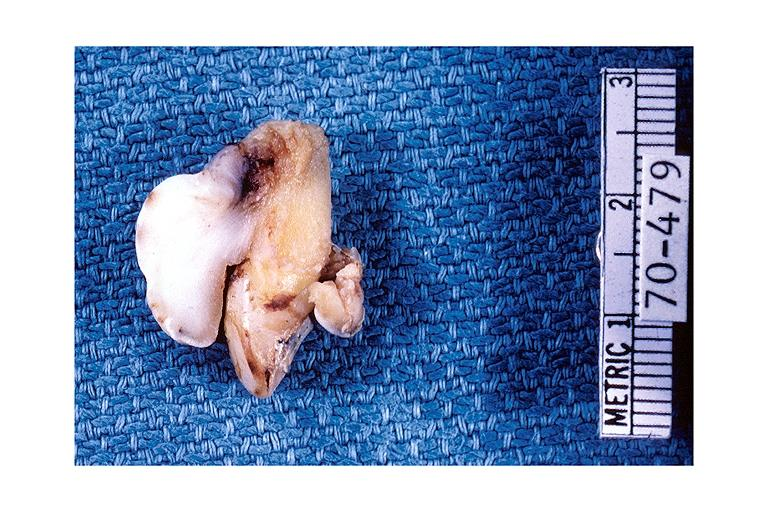s oral present?
Answer the question using a single word or phrase. Yes 